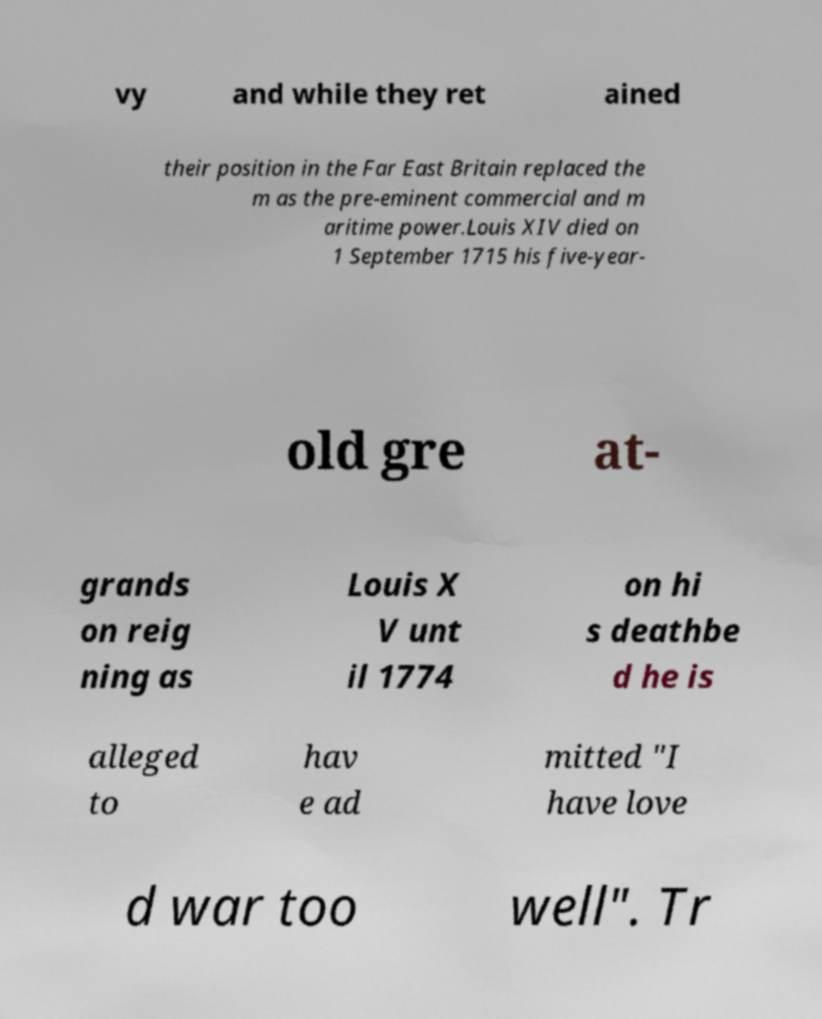Can you read and provide the text displayed in the image?This photo seems to have some interesting text. Can you extract and type it out for me? vy and while they ret ained their position in the Far East Britain replaced the m as the pre-eminent commercial and m aritime power.Louis XIV died on 1 September 1715 his five-year- old gre at- grands on reig ning as Louis X V unt il 1774 on hi s deathbe d he is alleged to hav e ad mitted "I have love d war too well". Tr 